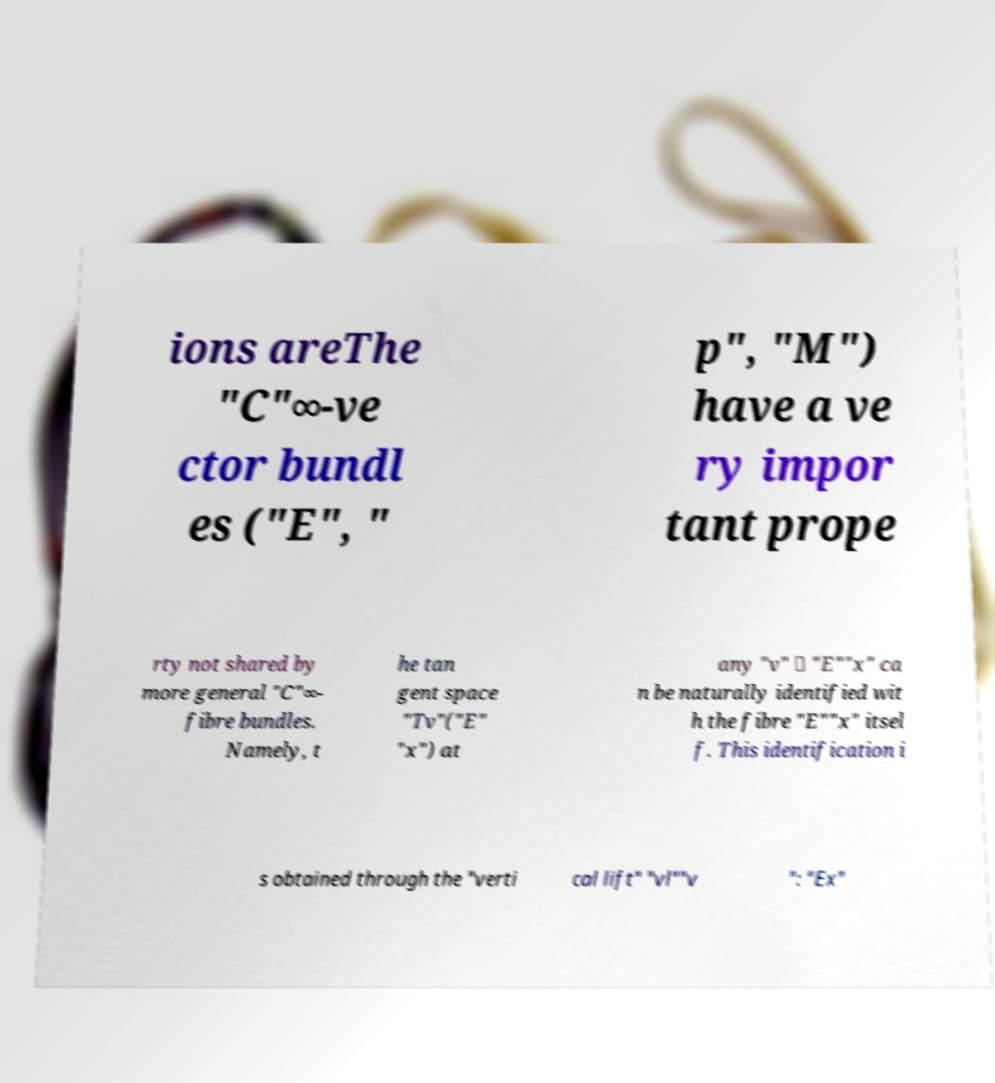Please identify and transcribe the text found in this image. ions areThe "C"∞-ve ctor bundl es ("E", " p", "M") have a ve ry impor tant prope rty not shared by more general "C"∞- fibre bundles. Namely, t he tan gent space "Tv"("E" "x") at any "v" ∈ "E""x" ca n be naturally identified wit h the fibre "E""x" itsel f. This identification i s obtained through the "verti cal lift" "vl""v ": "Ex" 